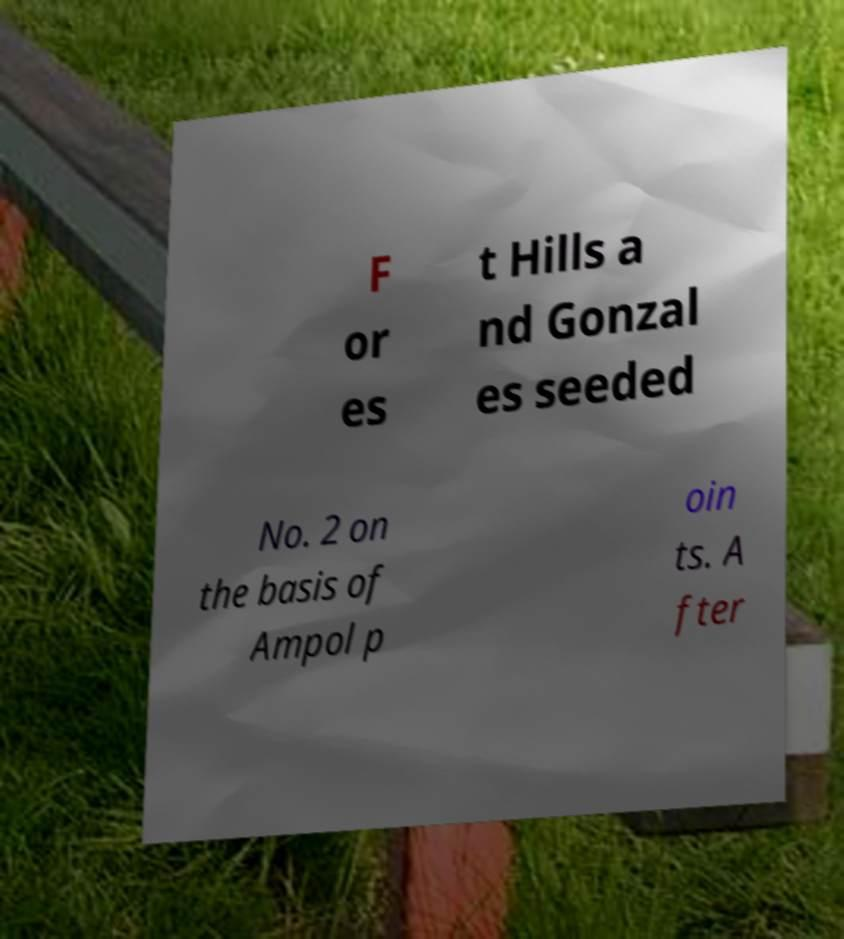Can you accurately transcribe the text from the provided image for me? F or es t Hills a nd Gonzal es seeded No. 2 on the basis of Ampol p oin ts. A fter 